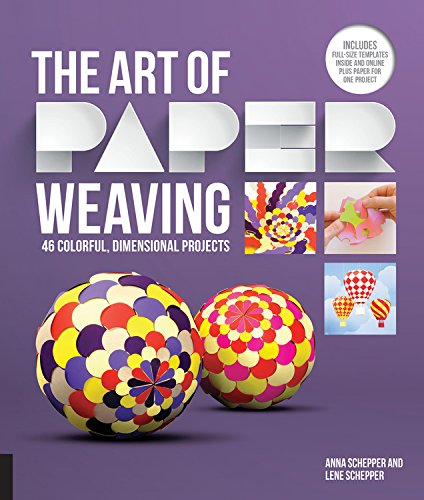Is this book related to Calendars? No, this book does not pertain to calendars. It is solely focused on the craft of paper weaving and creating colorful, three-dimensional projects. 